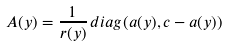<formula> <loc_0><loc_0><loc_500><loc_500>A ( y ) = \frac { 1 } { r ( y ) } \, d i a g ( a ( y ) , c - a ( y ) )</formula> 